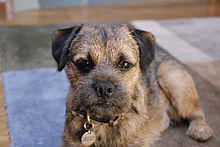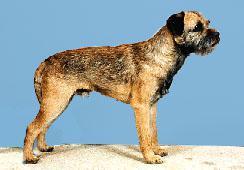The first image is the image on the left, the second image is the image on the right. Given the left and right images, does the statement "Left image shows one upright dog looking slightly downward and rightward." hold true? Answer yes or no. No. The first image is the image on the left, the second image is the image on the right. For the images displayed, is the sentence "A dog is wearing a collar." factually correct? Answer yes or no. Yes. 